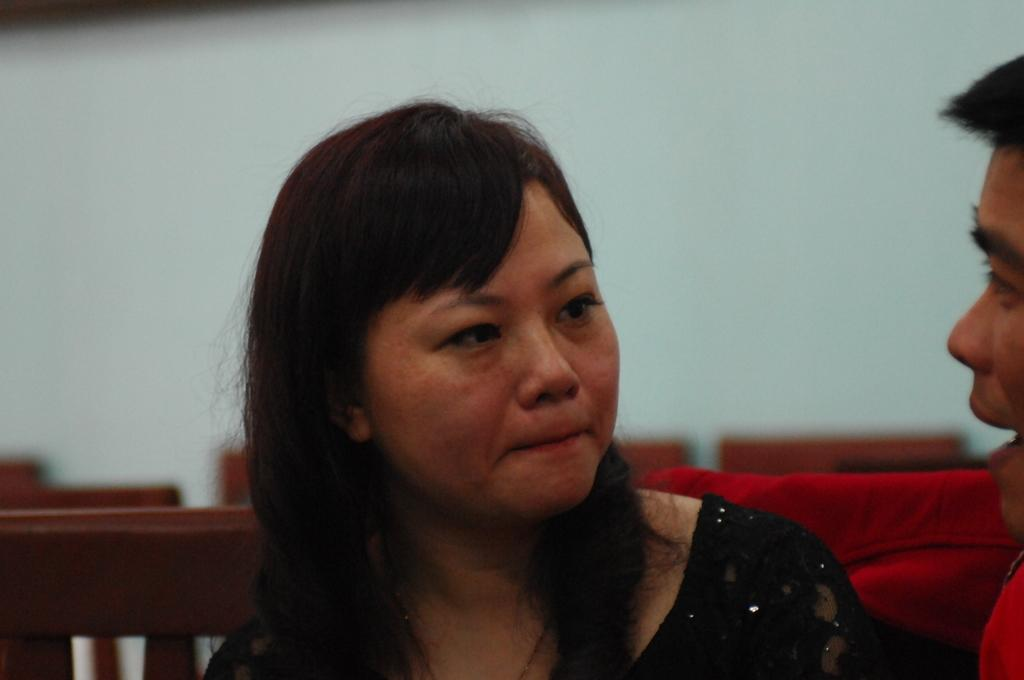How many individuals are present in the image? There are two people in the image. What can be seen behind the people in the image? There are items visible behind the people. What is the primary architectural feature in the background of the image? There is a wall in the background of the image. What is the weight of the truck visible in the image? There is no truck present in the image. Are there any servants visible in the image? The concept of servants is not mentioned or depicted in the image. 